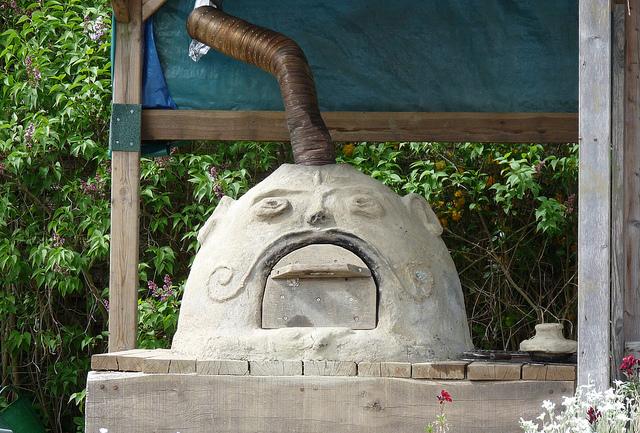What is this structure likely used for?
Be succinct. Baking. What material is the oven made out of?
Answer briefly. Clay. Are there people in the photo?
Answer briefly. No. 